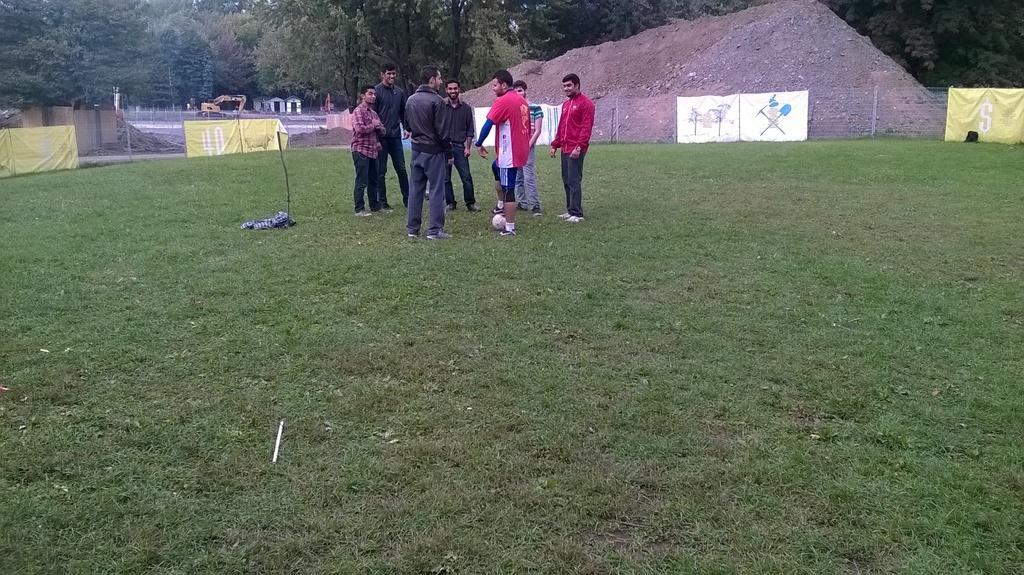In one or two sentences, can you explain what this image depicts? In the picture I can see few persons standing on a greenery ground and there is a fence,trees and few other objects in the background. 